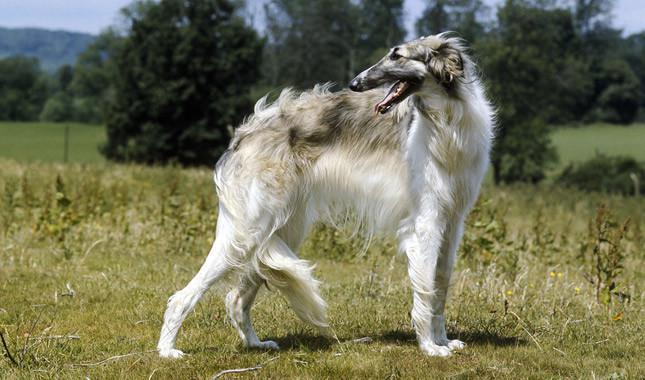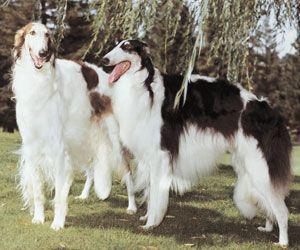The first image is the image on the left, the second image is the image on the right. Given the left and right images, does the statement "All dogs pictured are standing on all fours on grass, and the right image contains more dogs than the left." hold true? Answer yes or no. Yes. The first image is the image on the left, the second image is the image on the right. Considering the images on both sides, is "In one of the images there are two dogs standing in the grass in close proximity to each other." valid? Answer yes or no. Yes. 